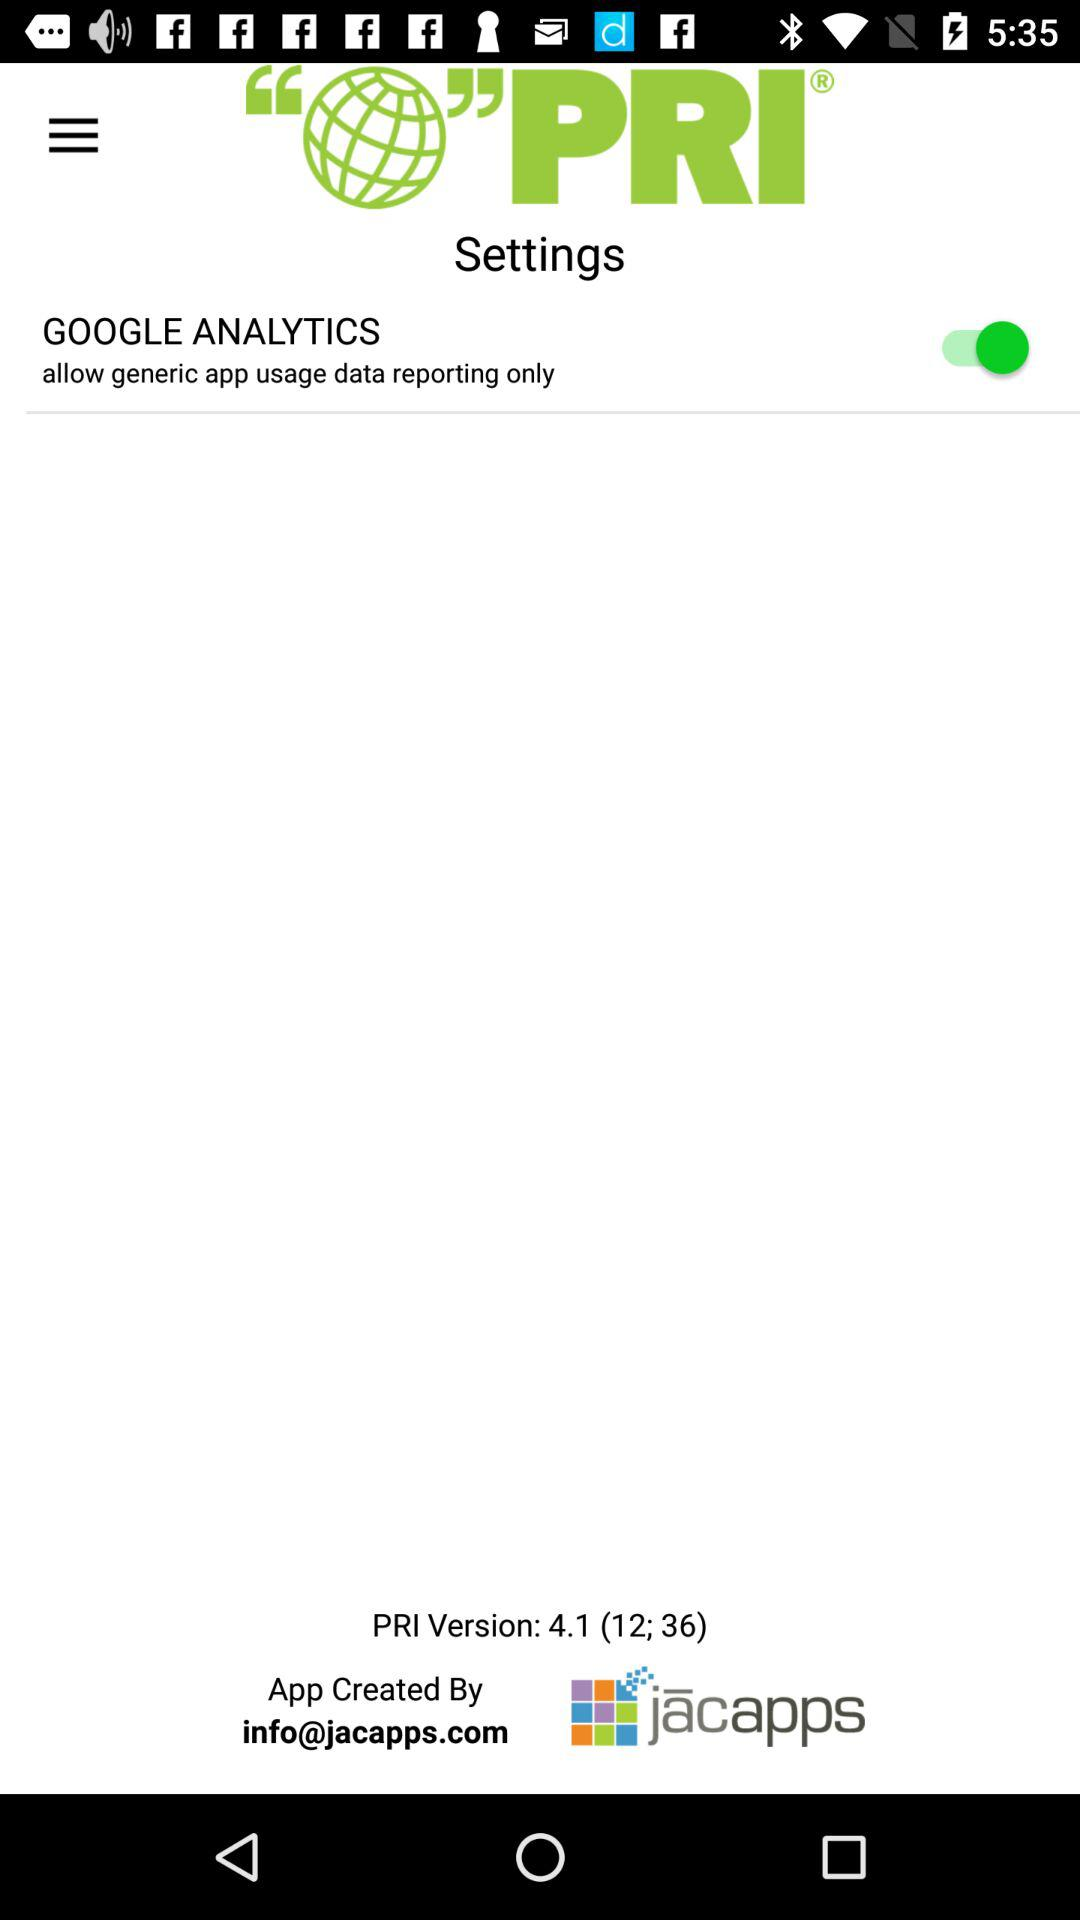What is the version of the application? The version of the application is 4.1 (12; 36). 